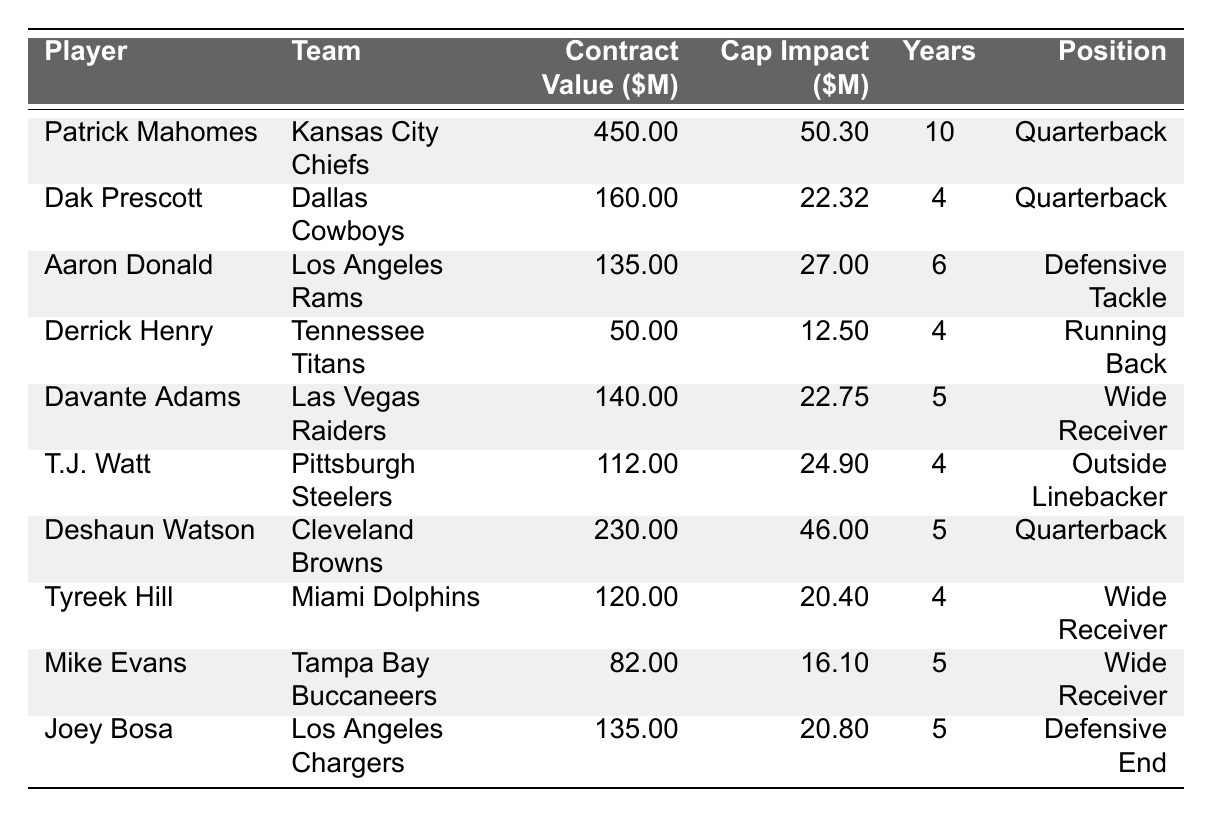What is the total contract value of all players listed in the table? To find the total contract value, we sum the individual contract values: 450 + 160 + 135 + 50 + 140 + 112 + 230 + 120 + 82 + 135 = 1,519 million dollars.
Answer: 1519 million dollars Which player has the highest salary cap impact? By comparing the salary cap impacts listed, Patrick Mahomes has the highest at 50.30 million dollars.
Answer: Patrick Mahomes How many years is Dak Prescott's contract? The contract length for Dak Prescott, as listed in the table, is 4 years.
Answer: 4 years What is the average salary cap impact of the players on the table? To calculate the average, we first sum the salary cap impacts: 50.30 + 22.32 + 27.00 + 12.50 + 22.75 + 24.90 + 46.00 + 20.40 + 16.10 + 20.80 =  243.07 million dollars. Then we divide by the number of players, which is 10: 243.07 / 10 = 24.31 million dollars.
Answer: 24.31 million dollars Is Deshaun Watson's contract value greater than Derrick Henry's? Comparing the two contract values, Deshaun Watson's is 230 million dollars while Derrick Henry's is 50 million dollars. Since 230 > 50, the statement is true.
Answer: Yes What position does the player with the highest contract value play? Patrick Mahomes has the highest contract value at 450 million dollars and he plays the Quarterback position.
Answer: Quarterback How much does Joey Bosa's contract value differ from Aaron Donald's? Joey Bosa's contract value is 135 million dollars and Aaron Donald's is 135 million dollars, so the difference is 135 - 135 = 0 million dollars.
Answer: 0 million dollars Which player's contract has the shortest length? The shortest contract length in the table is 4 years, which applies to both Dak Prescott and Derrick Henry.
Answer: Dak Prescott and Derrick Henry Which team has the player with the lowest contract value? The player with the lowest contract value is Derrick Henry at 50 million dollars, who plays for the Tennessee Titans.
Answer: Tennessee Titans What is the total salary cap impact for all wide receivers on the list? The wide receivers on the list are Davante Adams, Tyreek Hill, and Mike Evans. Their salary cap impacts are 22.75, 20.40, and 16.10 million dollars, respectively. Summing these values gives 22.75 + 20.40 + 16.10 = 59.25 million dollars.
Answer: 59.25 million dollars 